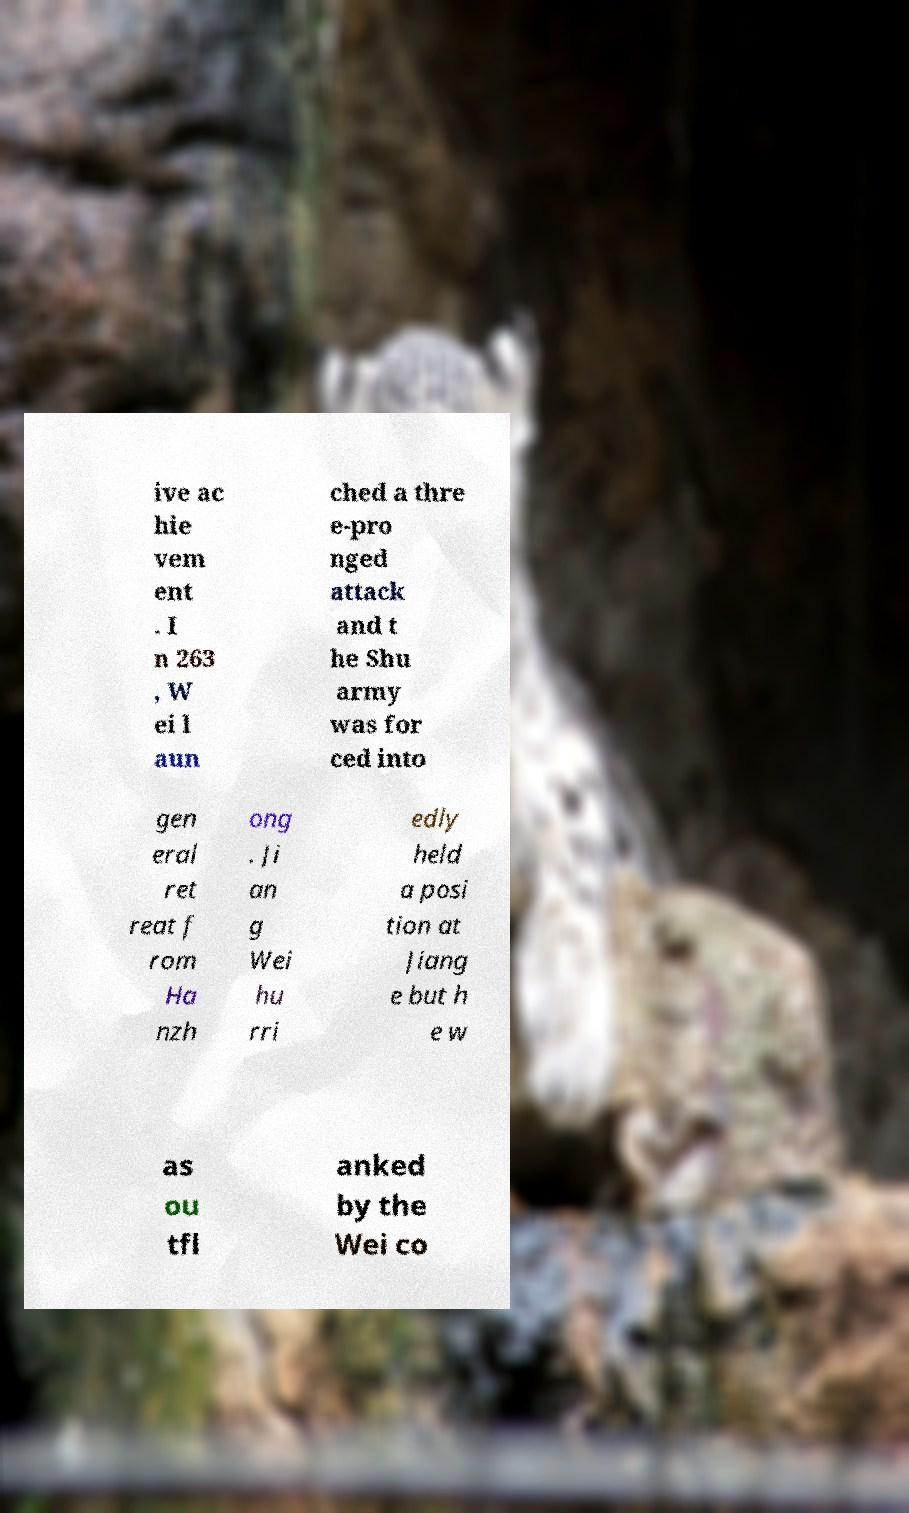Can you read and provide the text displayed in the image?This photo seems to have some interesting text. Can you extract and type it out for me? ive ac hie vem ent . I n 263 , W ei l aun ched a thre e-pro nged attack and t he Shu army was for ced into gen eral ret reat f rom Ha nzh ong . Ji an g Wei hu rri edly held a posi tion at Jiang e but h e w as ou tfl anked by the Wei co 